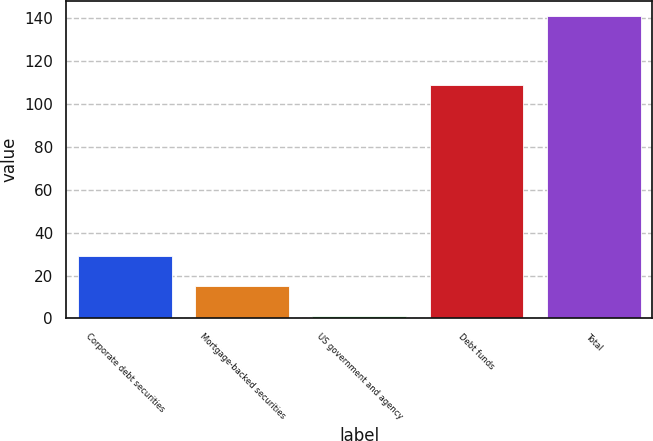Convert chart to OTSL. <chart><loc_0><loc_0><loc_500><loc_500><bar_chart><fcel>Corporate debt securities<fcel>Mortgage-backed securities<fcel>US government and agency<fcel>Debt funds<fcel>Total<nl><fcel>29<fcel>15<fcel>1<fcel>109<fcel>141<nl></chart> 